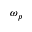Convert formula to latex. <formula><loc_0><loc_0><loc_500><loc_500>\omega _ { p }</formula> 